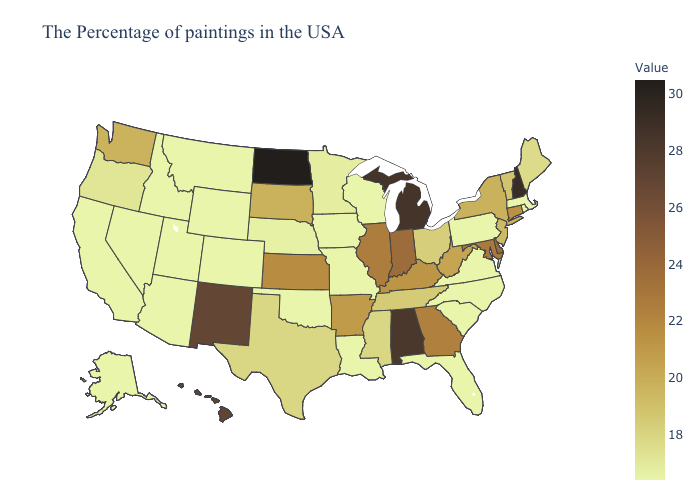Among the states that border Illinois , does Missouri have the highest value?
Give a very brief answer. No. Which states hav the highest value in the South?
Answer briefly. Alabama. 